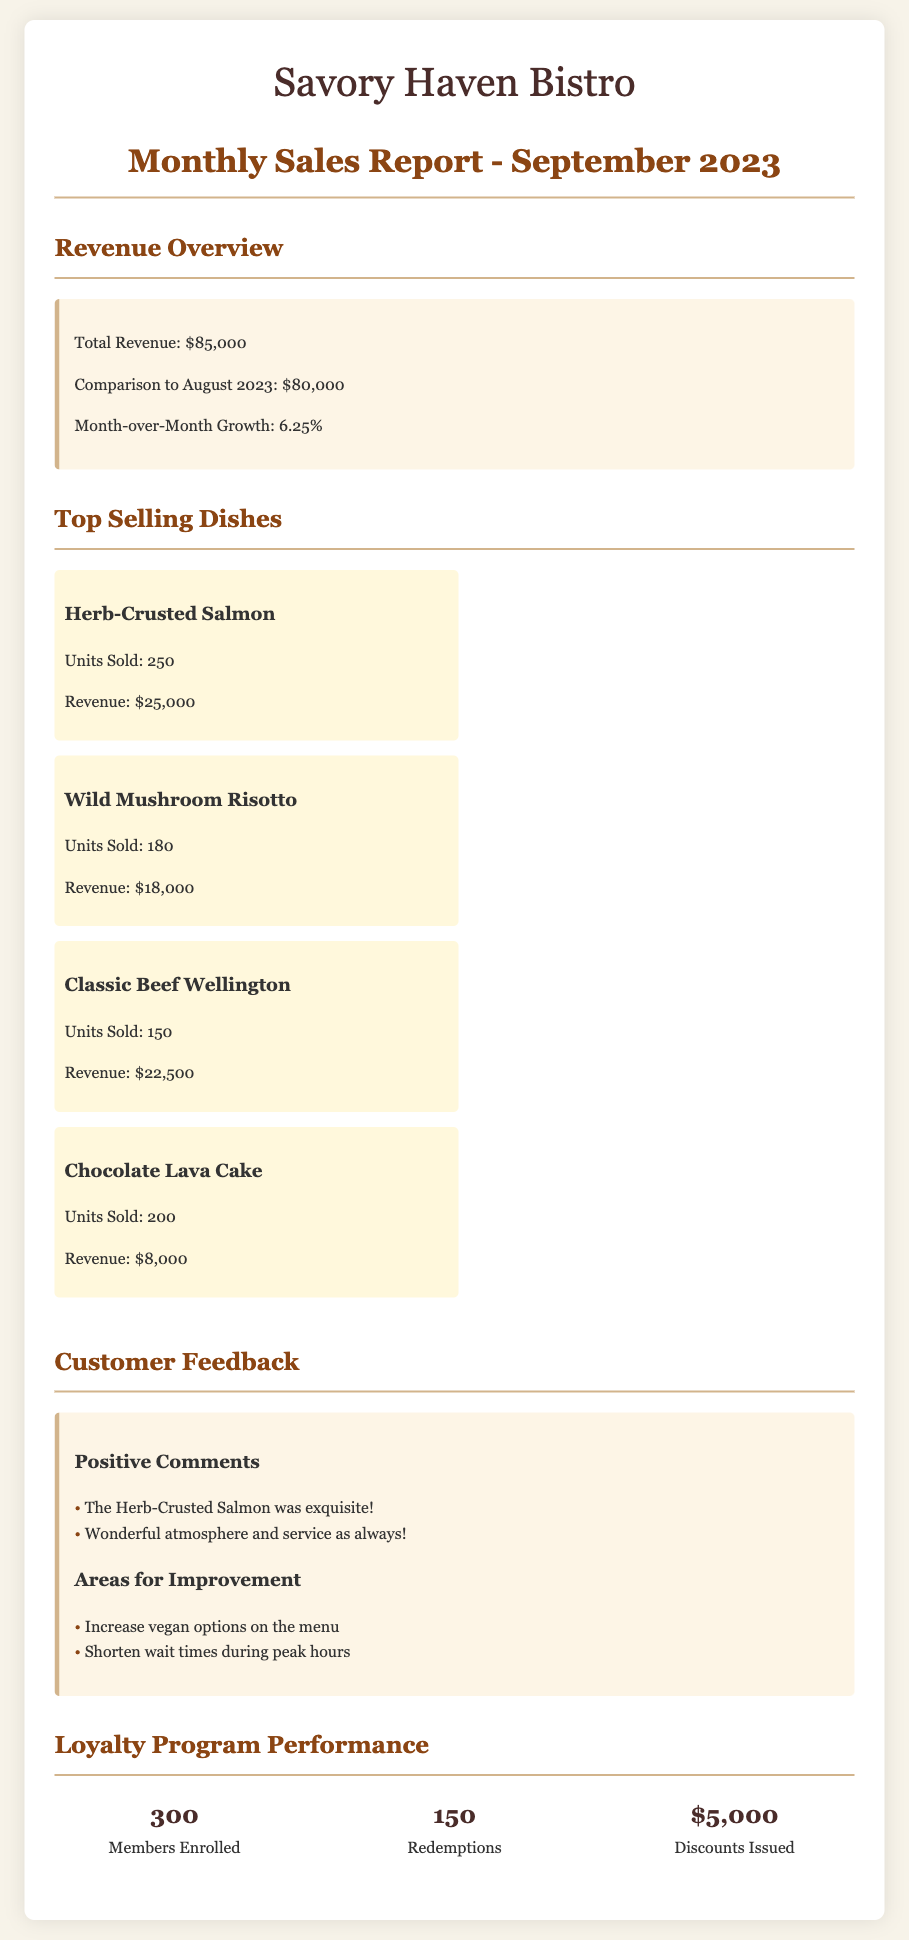What was the total revenue for September 2023? The total revenue for September 2023 is stated clearly in the document.
Answer: $85,000 What was the comparison of revenue to August 2023? The document provides a direct comparison of revenue between September and August 2023.
Answer: $80,000 How much did the Herb-Crusted Salmon make in revenue? The revenue generated by the Herb-Crusted Salmon is explicitly mentioned in the top-selling dishes section.
Answer: $25,000 How many units of Wild Mushroom Risotto were sold? The units sold for the Wild Mushroom Risotto is specified in the document.
Answer: 180 What is the month-over-month growth percentage? The growth percentage from August 2023 to September 2023 is given in the revenue overview section.
Answer: 6.25% Which dish had the highest units sold in September? The top-selling dish in terms of units sold is identified in the list of top-selling dishes.
Answer: Herb-Crusted Salmon How many loyalty program members are enrolled? The number of members enrolled in the loyalty program is detailed in the loyalty program performance section.
Answer: 300 What were the most common themes in customer feedback? The document summarizes the types of feedback received from customers in positive comments and areas for improvement.
Answer: Positive comments and areas for improvement What was the total amount of discounts issued? The document provides the total amount of discounts that were issued in the loyalty program performance section.
Answer: $5,000 